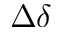Convert formula to latex. <formula><loc_0><loc_0><loc_500><loc_500>\Delta \delta</formula> 